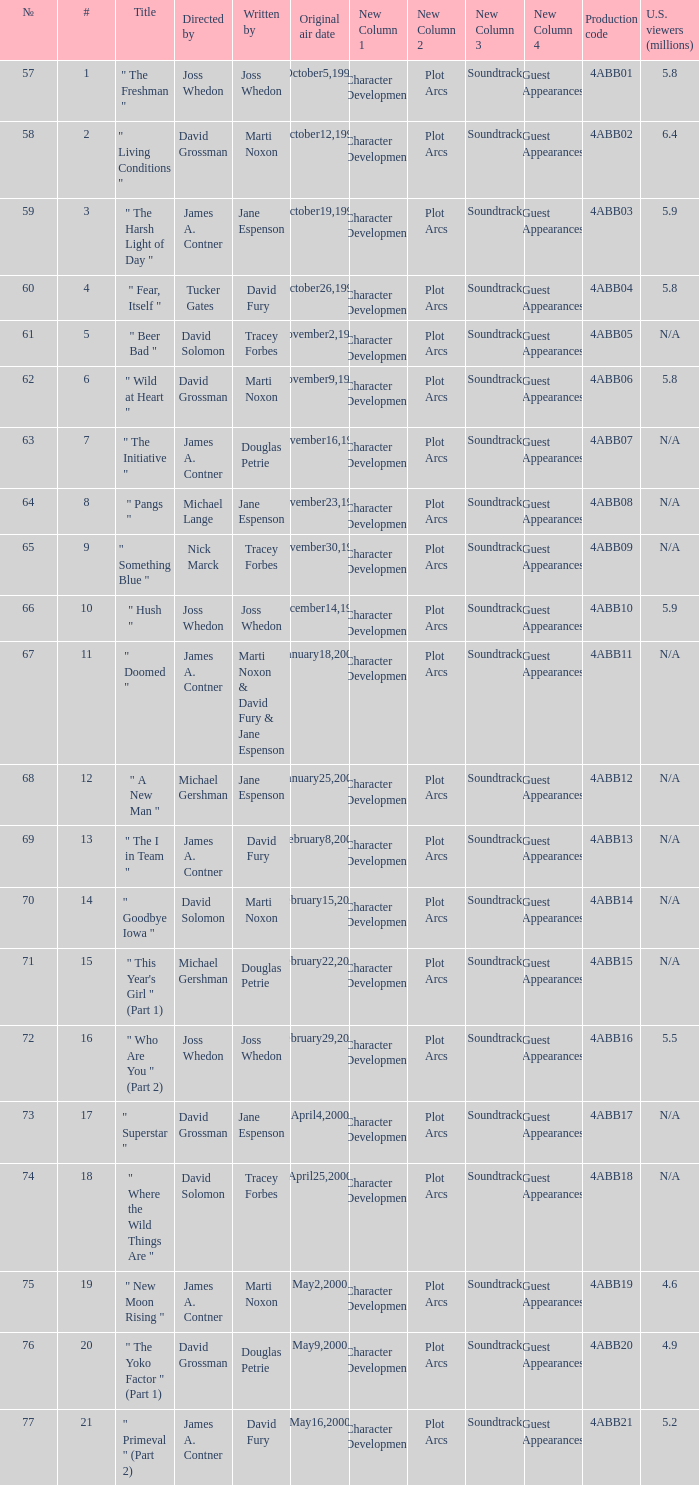Who wrote the episode which was directed by Nick Marck? Tracey Forbes. 